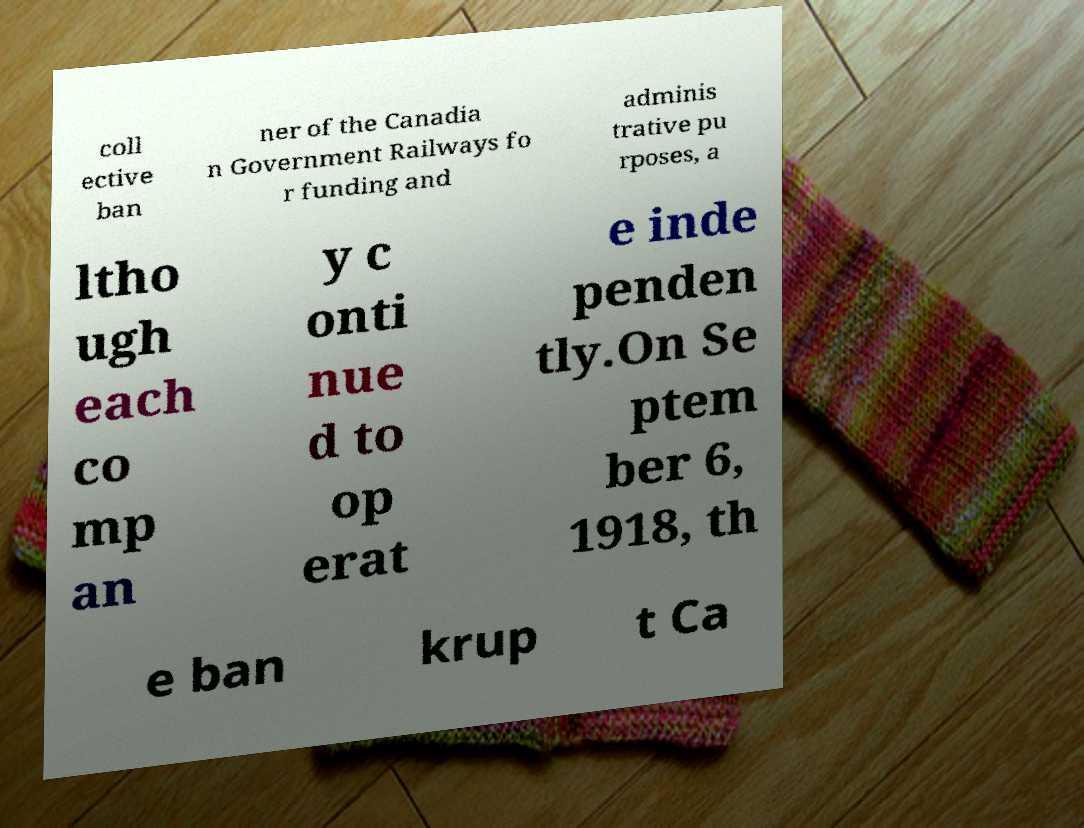Can you accurately transcribe the text from the provided image for me? coll ective ban ner of the Canadia n Government Railways fo r funding and adminis trative pu rposes, a ltho ugh each co mp an y c onti nue d to op erat e inde penden tly.On Se ptem ber 6, 1918, th e ban krup t Ca 